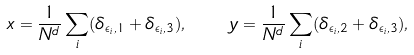Convert formula to latex. <formula><loc_0><loc_0><loc_500><loc_500>x = \frac { 1 } { N ^ { d } } \sum _ { i } ( \delta _ { \epsilon _ { i } , 1 } + \delta _ { \epsilon _ { i } , 3 } ) , \quad y = \frac { 1 } { N ^ { d } } \sum _ { i } ( \delta _ { \epsilon _ { i } , 2 } + \delta _ { \epsilon _ { i } , 3 } ) ,</formula> 